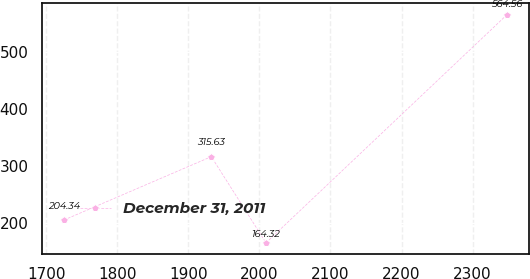Convert chart to OTSL. <chart><loc_0><loc_0><loc_500><loc_500><line_chart><ecel><fcel>December 31, 2011<nl><fcel>1724.88<fcel>204.34<nl><fcel>1932.32<fcel>315.63<nl><fcel>2009.3<fcel>164.32<nl><fcel>2348.22<fcel>564.56<nl></chart> 